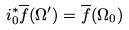<formula> <loc_0><loc_0><loc_500><loc_500>i _ { 0 } ^ { * } { \overline { f } } ( \Omega ^ { \prime } ) = { \overline { f } } ( \Omega _ { 0 } )</formula> 